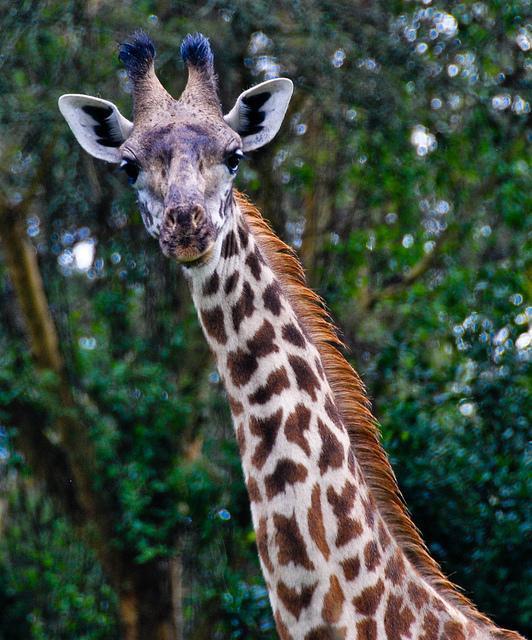How many animals are seen in the picture?
Give a very brief answer. 1. How many apples are being peeled?
Give a very brief answer. 0. 